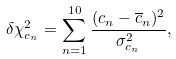<formula> <loc_0><loc_0><loc_500><loc_500>\delta \chi ^ { 2 } _ { c _ { n } } = \sum _ { n = 1 } ^ { 1 0 } \frac { ( c _ { n } - \overline { c } _ { n } ) ^ { 2 } } { \sigma ^ { 2 } _ { c _ { n } } } ,</formula> 